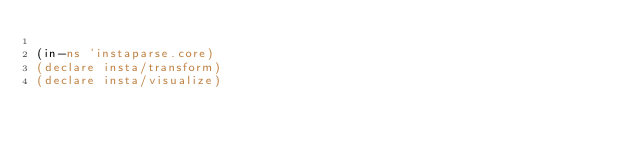Convert code to text. <code><loc_0><loc_0><loc_500><loc_500><_Clojure_>
(in-ns 'instaparse.core)
(declare insta/transform)
(declare insta/visualize)
</code> 